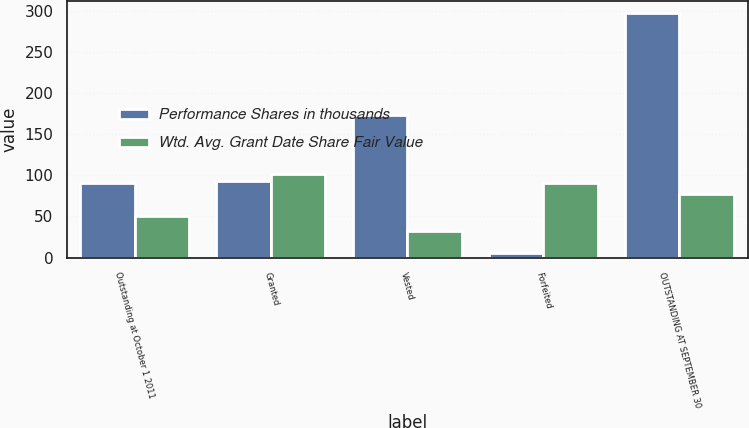Convert chart to OTSL. <chart><loc_0><loc_0><loc_500><loc_500><stacked_bar_chart><ecel><fcel>Outstanding at October 1 2011<fcel>Granted<fcel>Vested<fcel>Forfeited<fcel>OUTSTANDING AT SEPTEMBER 30<nl><fcel>Performance Shares in thousands<fcel>90.27<fcel>93<fcel>173<fcel>5<fcel>297<nl><fcel>Wtd. Avg. Grant Date Share Fair Value<fcel>50.7<fcel>101.57<fcel>31.82<fcel>90.27<fcel>76.84<nl></chart> 